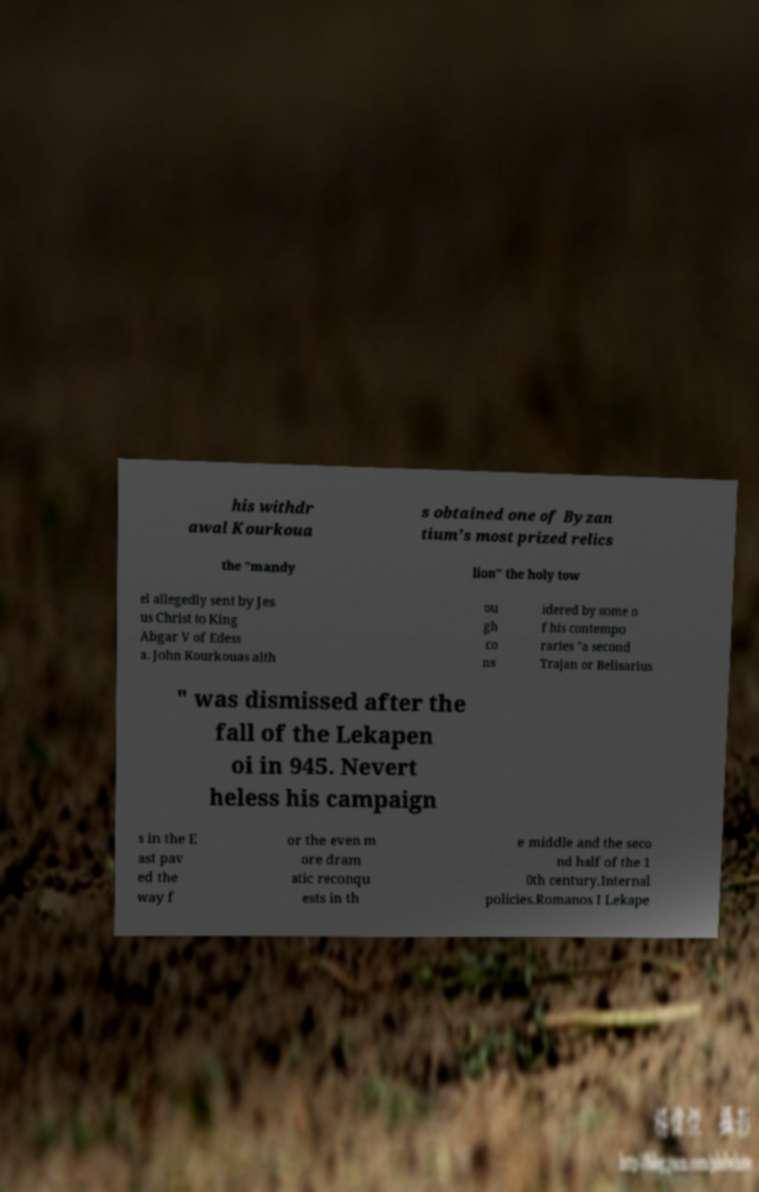I need the written content from this picture converted into text. Can you do that? his withdr awal Kourkoua s obtained one of Byzan tium's most prized relics the "mandy lion" the holy tow el allegedly sent by Jes us Christ to King Abgar V of Edess a. John Kourkouas alth ou gh co ns idered by some o f his contempo raries "a second Trajan or Belisarius " was dismissed after the fall of the Lekapen oi in 945. Nevert heless his campaign s in the E ast pav ed the way f or the even m ore dram atic reconqu ests in th e middle and the seco nd half of the 1 0th century.Internal policies.Romanos I Lekape 